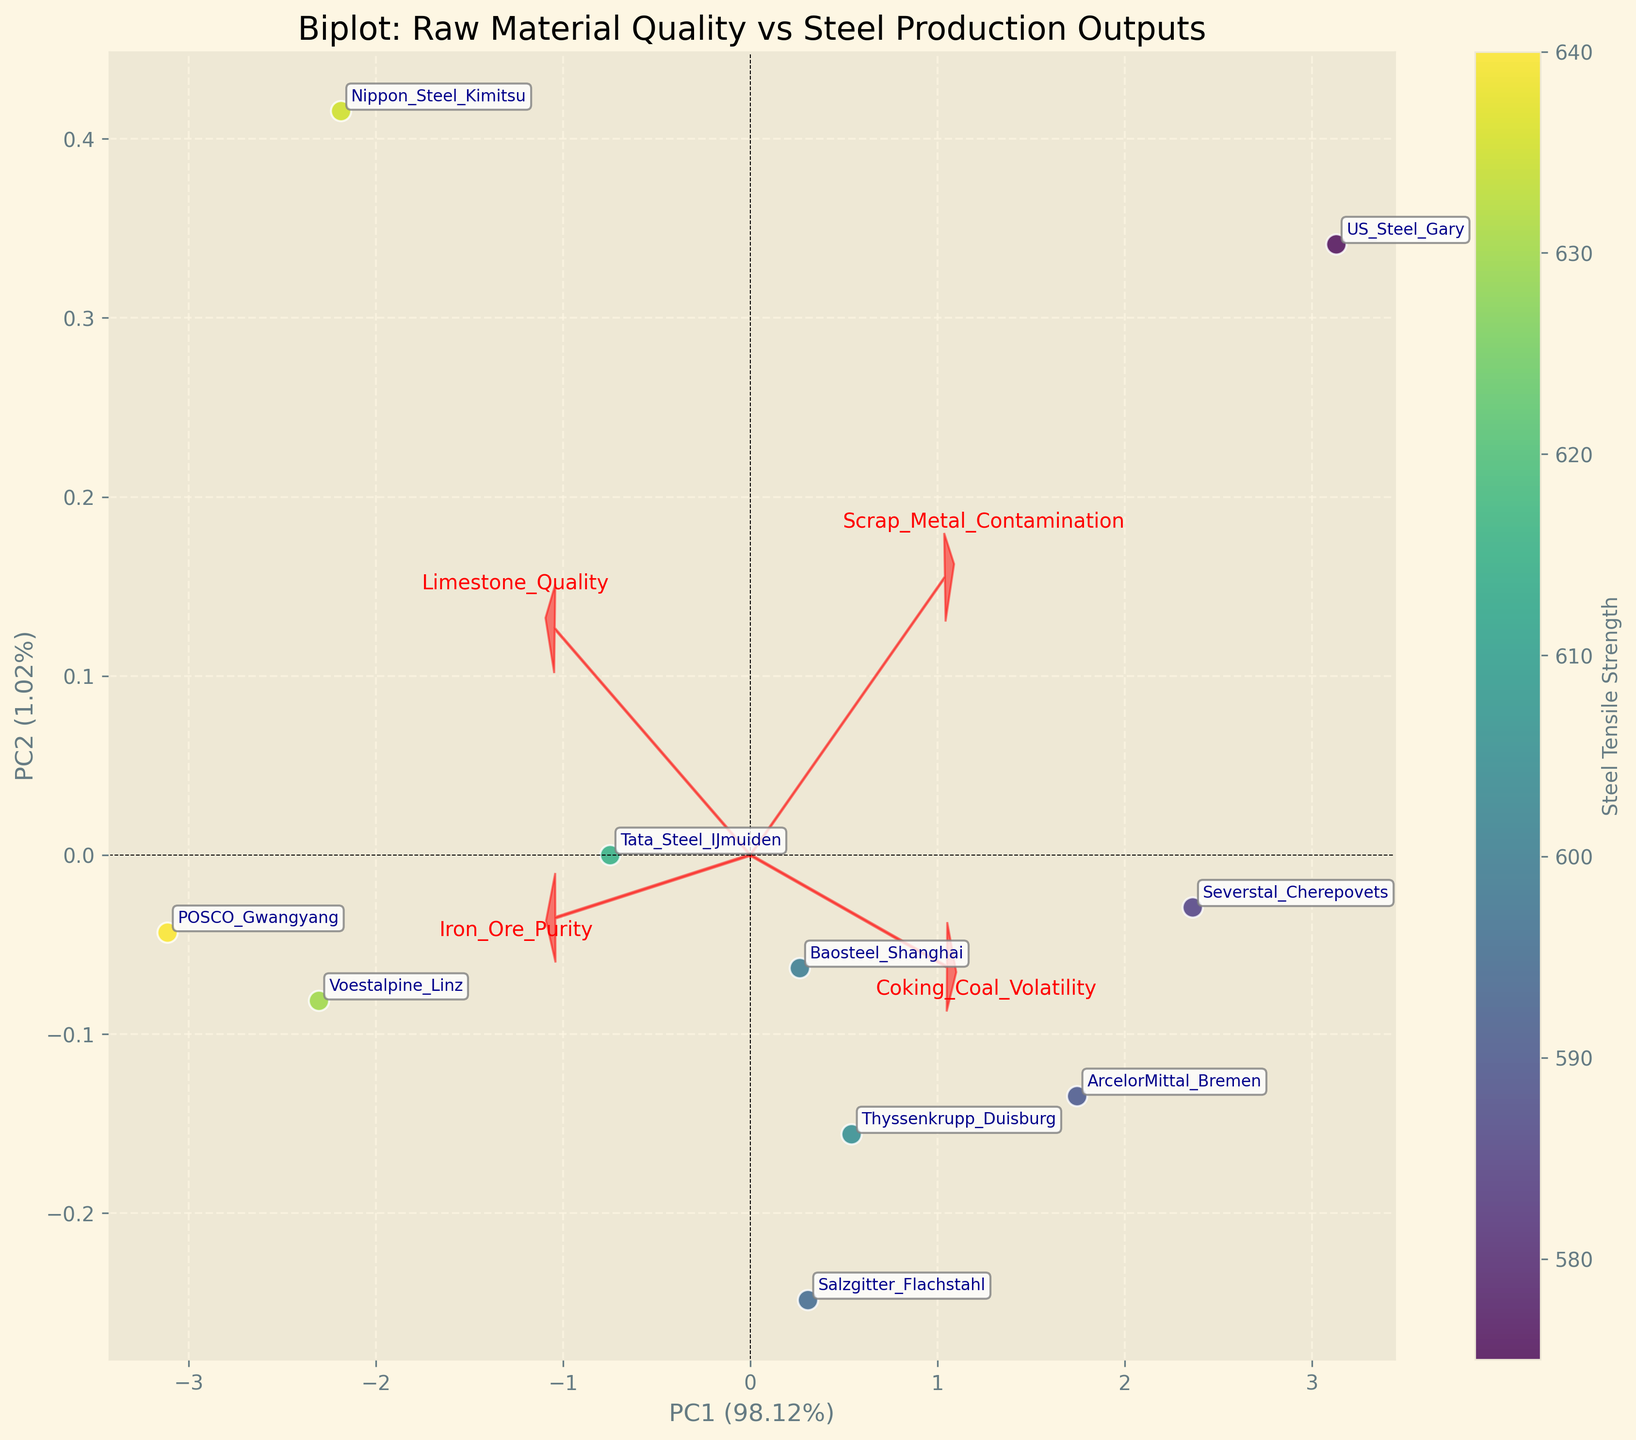what is the title of the figure? The title of the figure is displayed at the top and reads 'Biplot: Raw Material Quality vs Steel Production Outputs'
Answer: Biplot: Raw Material Quality vs Steel Production Outputs How many data points (factories) are plotted in the figure? By counting the number of annotations, we can see that there are 10 factories
Answer: 10 Which factory has the highest Steel Tensile Strength and where is it located on the plot? The colorbar indicates that the color intensity represents Steel Tensile Strength. POSCO_Gwangyang, which is colored the most intensely, has the highest Steel Tensile Strength. It is located towards the right and slightly up on the plot
Answer: POSCO_Gwangyang Where is the 'Iron_Ore_Purity' loading vector pointing, and what does it indicate? The 'Iron_Ore_Purity' loading vector is pointing towards the right. This indicates that higher values of Iron Ore Purity are associated with factories plotted towards the right of the plot
Answer: Right, indicating higher Iron Ore Purity values Based on the plot, which factor negatively correlates with 'Scrap_Metal_Contamination'? The loading vector for 'Scrap_Metal_Contamination' points to the opposite direction of several other factors like 'Limestone_Quality' and 'Coking_Coal_Volatility', indicating a negative correlation
Answer: Limestone_Quality and Coking_Coal_Volatility Which factories are located on the positive side of both PC1 and PC2 axes? By visually checking the plot, POSCO_Gwangyang and Voestalpine_Linz are located on the positive side of both PC1 and PC2
Answer: POSCO_Gwangyang and Voestalpine_Linz Compare the Steel Yield Rates of factories placed between -2 and -1 on the PC1 axis. Which one is higher? The factories between -2 and -1 on the PC1 axis are US_Steel_Gary and Severstal_Cherepovets. A comparison shows US_Steel_Gary has a higher Steel Yield Rate.
Answer: US_Steel_Gary What does the color scale represent, and how does it help in interpreting the plot? The color scale represents Steel Tensile Strength, which helps to visually distinguish which factories have higher or lower tensile strengths by their color
Answer: Steel Tensile Strength Calculate the total number of loading vectors shown in the plot. Each loading vector represents one raw material quality metric. Counting the labels associated with the vectors gives the total number, which is 4
Answer: 4 